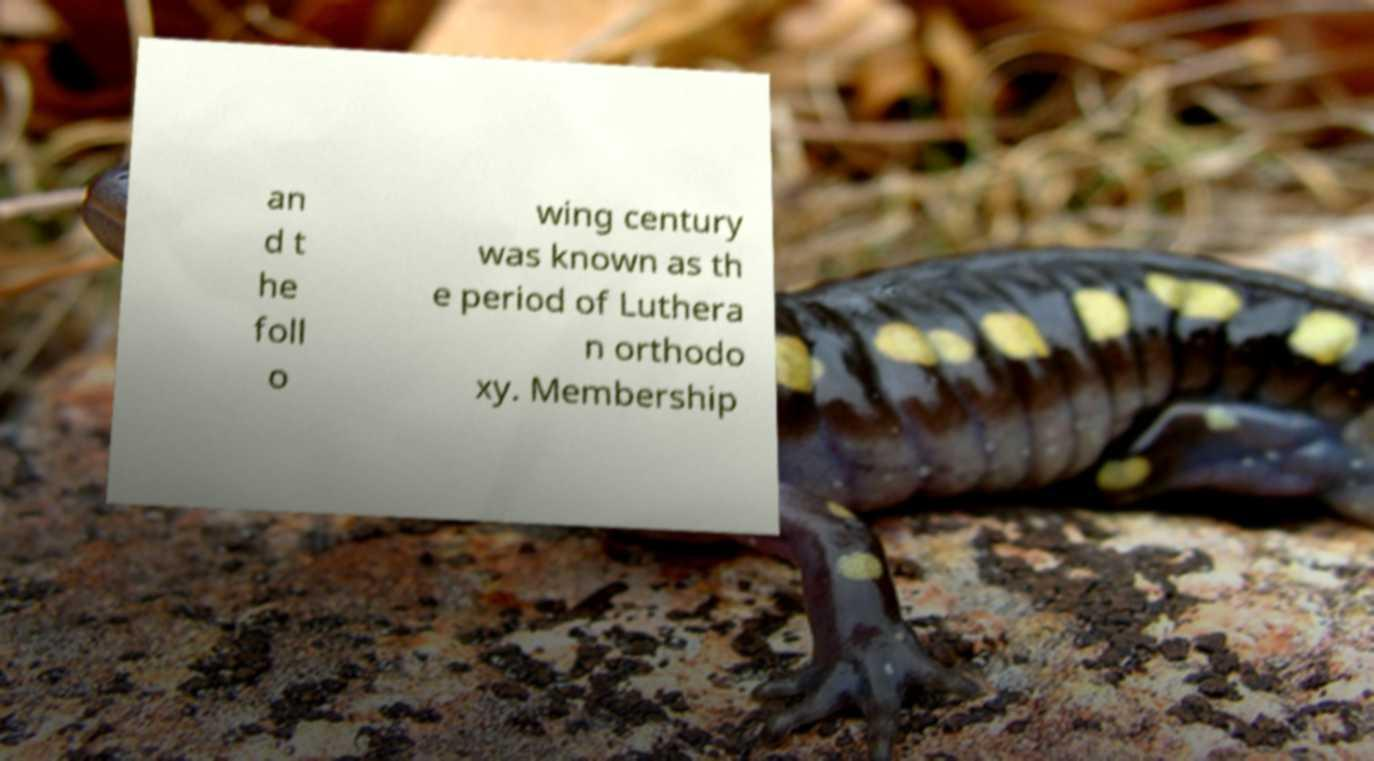Could you extract and type out the text from this image? an d t he foll o wing century was known as th e period of Luthera n orthodo xy. Membership 